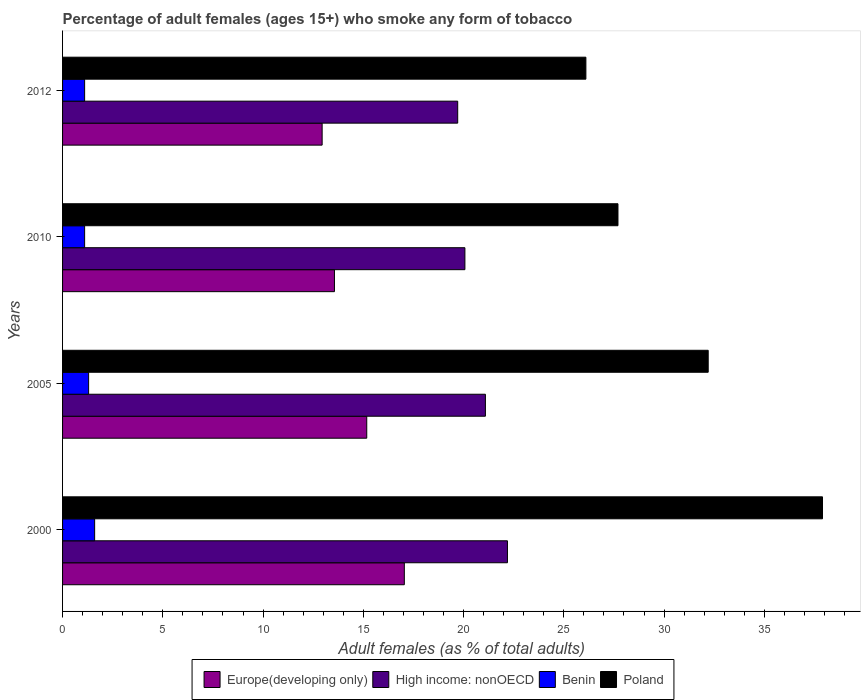How many different coloured bars are there?
Your response must be concise. 4. How many groups of bars are there?
Offer a very short reply. 4. What is the percentage of adult females who smoke in Benin in 2012?
Provide a short and direct response. 1.1. Across all years, what is the maximum percentage of adult females who smoke in Europe(developing only)?
Provide a succinct answer. 17.04. Across all years, what is the minimum percentage of adult females who smoke in Europe(developing only)?
Ensure brevity in your answer.  12.95. What is the difference between the percentage of adult females who smoke in High income: nonOECD in 2005 and that in 2012?
Keep it short and to the point. 1.38. What is the difference between the percentage of adult females who smoke in High income: nonOECD in 2010 and the percentage of adult females who smoke in Poland in 2012?
Your answer should be very brief. -6.03. What is the average percentage of adult females who smoke in Europe(developing only) per year?
Provide a short and direct response. 14.68. In the year 2000, what is the difference between the percentage of adult females who smoke in High income: nonOECD and percentage of adult females who smoke in Europe(developing only)?
Ensure brevity in your answer.  5.14. What is the ratio of the percentage of adult females who smoke in High income: nonOECD in 2010 to that in 2012?
Ensure brevity in your answer.  1.02. What is the difference between the highest and the second highest percentage of adult females who smoke in Europe(developing only)?
Provide a short and direct response. 1.87. What is the difference between the highest and the lowest percentage of adult females who smoke in Europe(developing only)?
Your response must be concise. 4.1. In how many years, is the percentage of adult females who smoke in High income: nonOECD greater than the average percentage of adult females who smoke in High income: nonOECD taken over all years?
Offer a terse response. 2. What does the 2nd bar from the top in 2005 represents?
Provide a succinct answer. Benin. What does the 4th bar from the bottom in 2012 represents?
Ensure brevity in your answer.  Poland. Is it the case that in every year, the sum of the percentage of adult females who smoke in Europe(developing only) and percentage of adult females who smoke in Benin is greater than the percentage of adult females who smoke in High income: nonOECD?
Provide a short and direct response. No. How many bars are there?
Keep it short and to the point. 16. Are all the bars in the graph horizontal?
Your response must be concise. Yes. How many years are there in the graph?
Provide a succinct answer. 4. What is the difference between two consecutive major ticks on the X-axis?
Provide a short and direct response. 5. Are the values on the major ticks of X-axis written in scientific E-notation?
Your answer should be very brief. No. Does the graph contain any zero values?
Your answer should be very brief. No. How are the legend labels stacked?
Your answer should be compact. Horizontal. What is the title of the graph?
Offer a very short reply. Percentage of adult females (ages 15+) who smoke any form of tobacco. Does "Nepal" appear as one of the legend labels in the graph?
Ensure brevity in your answer.  No. What is the label or title of the X-axis?
Ensure brevity in your answer.  Adult females (as % of total adults). What is the Adult females (as % of total adults) of Europe(developing only) in 2000?
Provide a succinct answer. 17.04. What is the Adult females (as % of total adults) of High income: nonOECD in 2000?
Provide a short and direct response. 22.19. What is the Adult females (as % of total adults) in Poland in 2000?
Ensure brevity in your answer.  37.9. What is the Adult females (as % of total adults) in Europe(developing only) in 2005?
Provide a short and direct response. 15.17. What is the Adult females (as % of total adults) in High income: nonOECD in 2005?
Make the answer very short. 21.09. What is the Adult females (as % of total adults) of Poland in 2005?
Offer a very short reply. 32.2. What is the Adult females (as % of total adults) in Europe(developing only) in 2010?
Your answer should be very brief. 13.56. What is the Adult females (as % of total adults) of High income: nonOECD in 2010?
Your answer should be very brief. 20.07. What is the Adult females (as % of total adults) of Benin in 2010?
Offer a very short reply. 1.1. What is the Adult females (as % of total adults) of Poland in 2010?
Provide a succinct answer. 27.7. What is the Adult females (as % of total adults) in Europe(developing only) in 2012?
Your answer should be very brief. 12.95. What is the Adult females (as % of total adults) of High income: nonOECD in 2012?
Your response must be concise. 19.71. What is the Adult females (as % of total adults) of Poland in 2012?
Offer a terse response. 26.1. Across all years, what is the maximum Adult females (as % of total adults) of Europe(developing only)?
Your response must be concise. 17.04. Across all years, what is the maximum Adult females (as % of total adults) in High income: nonOECD?
Your answer should be very brief. 22.19. Across all years, what is the maximum Adult females (as % of total adults) in Poland?
Make the answer very short. 37.9. Across all years, what is the minimum Adult females (as % of total adults) in Europe(developing only)?
Offer a terse response. 12.95. Across all years, what is the minimum Adult females (as % of total adults) of High income: nonOECD?
Your answer should be compact. 19.71. Across all years, what is the minimum Adult females (as % of total adults) of Poland?
Your answer should be very brief. 26.1. What is the total Adult females (as % of total adults) of Europe(developing only) in the graph?
Make the answer very short. 58.72. What is the total Adult females (as % of total adults) of High income: nonOECD in the graph?
Make the answer very short. 83.05. What is the total Adult females (as % of total adults) in Poland in the graph?
Provide a succinct answer. 123.9. What is the difference between the Adult females (as % of total adults) in Europe(developing only) in 2000 and that in 2005?
Keep it short and to the point. 1.87. What is the difference between the Adult females (as % of total adults) of High income: nonOECD in 2000 and that in 2005?
Your answer should be very brief. 1.1. What is the difference between the Adult females (as % of total adults) of Benin in 2000 and that in 2005?
Provide a succinct answer. 0.3. What is the difference between the Adult females (as % of total adults) of Europe(developing only) in 2000 and that in 2010?
Make the answer very short. 3.48. What is the difference between the Adult females (as % of total adults) in High income: nonOECD in 2000 and that in 2010?
Keep it short and to the point. 2.12. What is the difference between the Adult females (as % of total adults) in Benin in 2000 and that in 2010?
Offer a terse response. 0.5. What is the difference between the Adult females (as % of total adults) of Poland in 2000 and that in 2010?
Keep it short and to the point. 10.2. What is the difference between the Adult females (as % of total adults) of Europe(developing only) in 2000 and that in 2012?
Offer a terse response. 4.1. What is the difference between the Adult females (as % of total adults) of High income: nonOECD in 2000 and that in 2012?
Make the answer very short. 2.48. What is the difference between the Adult females (as % of total adults) in Poland in 2000 and that in 2012?
Offer a terse response. 11.8. What is the difference between the Adult females (as % of total adults) of Europe(developing only) in 2005 and that in 2010?
Give a very brief answer. 1.61. What is the difference between the Adult females (as % of total adults) in High income: nonOECD in 2005 and that in 2010?
Ensure brevity in your answer.  1.02. What is the difference between the Adult females (as % of total adults) in Benin in 2005 and that in 2010?
Your answer should be compact. 0.2. What is the difference between the Adult females (as % of total adults) in Poland in 2005 and that in 2010?
Provide a succinct answer. 4.5. What is the difference between the Adult females (as % of total adults) in Europe(developing only) in 2005 and that in 2012?
Offer a terse response. 2.22. What is the difference between the Adult females (as % of total adults) in High income: nonOECD in 2005 and that in 2012?
Provide a succinct answer. 1.38. What is the difference between the Adult females (as % of total adults) of Benin in 2005 and that in 2012?
Make the answer very short. 0.2. What is the difference between the Adult females (as % of total adults) in Poland in 2005 and that in 2012?
Give a very brief answer. 6.1. What is the difference between the Adult females (as % of total adults) of Europe(developing only) in 2010 and that in 2012?
Make the answer very short. 0.61. What is the difference between the Adult females (as % of total adults) in High income: nonOECD in 2010 and that in 2012?
Your answer should be very brief. 0.36. What is the difference between the Adult females (as % of total adults) in Benin in 2010 and that in 2012?
Make the answer very short. 0. What is the difference between the Adult females (as % of total adults) in Poland in 2010 and that in 2012?
Keep it short and to the point. 1.6. What is the difference between the Adult females (as % of total adults) of Europe(developing only) in 2000 and the Adult females (as % of total adults) of High income: nonOECD in 2005?
Your answer should be very brief. -4.04. What is the difference between the Adult females (as % of total adults) of Europe(developing only) in 2000 and the Adult females (as % of total adults) of Benin in 2005?
Make the answer very short. 15.74. What is the difference between the Adult females (as % of total adults) in Europe(developing only) in 2000 and the Adult females (as % of total adults) in Poland in 2005?
Give a very brief answer. -15.16. What is the difference between the Adult females (as % of total adults) of High income: nonOECD in 2000 and the Adult females (as % of total adults) of Benin in 2005?
Your response must be concise. 20.89. What is the difference between the Adult females (as % of total adults) of High income: nonOECD in 2000 and the Adult females (as % of total adults) of Poland in 2005?
Offer a very short reply. -10.01. What is the difference between the Adult females (as % of total adults) of Benin in 2000 and the Adult females (as % of total adults) of Poland in 2005?
Offer a terse response. -30.6. What is the difference between the Adult females (as % of total adults) in Europe(developing only) in 2000 and the Adult females (as % of total adults) in High income: nonOECD in 2010?
Your answer should be compact. -3.02. What is the difference between the Adult females (as % of total adults) of Europe(developing only) in 2000 and the Adult females (as % of total adults) of Benin in 2010?
Your answer should be compact. 15.94. What is the difference between the Adult females (as % of total adults) in Europe(developing only) in 2000 and the Adult females (as % of total adults) in Poland in 2010?
Your answer should be compact. -10.66. What is the difference between the Adult females (as % of total adults) of High income: nonOECD in 2000 and the Adult females (as % of total adults) of Benin in 2010?
Your response must be concise. 21.09. What is the difference between the Adult females (as % of total adults) in High income: nonOECD in 2000 and the Adult females (as % of total adults) in Poland in 2010?
Your response must be concise. -5.51. What is the difference between the Adult females (as % of total adults) of Benin in 2000 and the Adult females (as % of total adults) of Poland in 2010?
Offer a terse response. -26.1. What is the difference between the Adult females (as % of total adults) in Europe(developing only) in 2000 and the Adult females (as % of total adults) in High income: nonOECD in 2012?
Your answer should be compact. -2.66. What is the difference between the Adult females (as % of total adults) in Europe(developing only) in 2000 and the Adult females (as % of total adults) in Benin in 2012?
Make the answer very short. 15.94. What is the difference between the Adult females (as % of total adults) of Europe(developing only) in 2000 and the Adult females (as % of total adults) of Poland in 2012?
Offer a terse response. -9.06. What is the difference between the Adult females (as % of total adults) of High income: nonOECD in 2000 and the Adult females (as % of total adults) of Benin in 2012?
Your answer should be compact. 21.09. What is the difference between the Adult females (as % of total adults) in High income: nonOECD in 2000 and the Adult females (as % of total adults) in Poland in 2012?
Your answer should be compact. -3.91. What is the difference between the Adult females (as % of total adults) in Benin in 2000 and the Adult females (as % of total adults) in Poland in 2012?
Offer a very short reply. -24.5. What is the difference between the Adult females (as % of total adults) of Europe(developing only) in 2005 and the Adult females (as % of total adults) of High income: nonOECD in 2010?
Offer a very short reply. -4.9. What is the difference between the Adult females (as % of total adults) of Europe(developing only) in 2005 and the Adult females (as % of total adults) of Benin in 2010?
Provide a succinct answer. 14.07. What is the difference between the Adult females (as % of total adults) of Europe(developing only) in 2005 and the Adult females (as % of total adults) of Poland in 2010?
Your response must be concise. -12.53. What is the difference between the Adult females (as % of total adults) in High income: nonOECD in 2005 and the Adult females (as % of total adults) in Benin in 2010?
Offer a very short reply. 19.99. What is the difference between the Adult females (as % of total adults) in High income: nonOECD in 2005 and the Adult females (as % of total adults) in Poland in 2010?
Offer a very short reply. -6.61. What is the difference between the Adult females (as % of total adults) in Benin in 2005 and the Adult females (as % of total adults) in Poland in 2010?
Keep it short and to the point. -26.4. What is the difference between the Adult females (as % of total adults) in Europe(developing only) in 2005 and the Adult females (as % of total adults) in High income: nonOECD in 2012?
Your answer should be very brief. -4.54. What is the difference between the Adult females (as % of total adults) in Europe(developing only) in 2005 and the Adult females (as % of total adults) in Benin in 2012?
Give a very brief answer. 14.07. What is the difference between the Adult females (as % of total adults) of Europe(developing only) in 2005 and the Adult females (as % of total adults) of Poland in 2012?
Make the answer very short. -10.93. What is the difference between the Adult females (as % of total adults) in High income: nonOECD in 2005 and the Adult females (as % of total adults) in Benin in 2012?
Provide a succinct answer. 19.99. What is the difference between the Adult females (as % of total adults) in High income: nonOECD in 2005 and the Adult females (as % of total adults) in Poland in 2012?
Your response must be concise. -5.01. What is the difference between the Adult females (as % of total adults) of Benin in 2005 and the Adult females (as % of total adults) of Poland in 2012?
Keep it short and to the point. -24.8. What is the difference between the Adult females (as % of total adults) of Europe(developing only) in 2010 and the Adult females (as % of total adults) of High income: nonOECD in 2012?
Your answer should be compact. -6.15. What is the difference between the Adult females (as % of total adults) of Europe(developing only) in 2010 and the Adult females (as % of total adults) of Benin in 2012?
Your answer should be compact. 12.46. What is the difference between the Adult females (as % of total adults) of Europe(developing only) in 2010 and the Adult females (as % of total adults) of Poland in 2012?
Your answer should be compact. -12.54. What is the difference between the Adult females (as % of total adults) in High income: nonOECD in 2010 and the Adult females (as % of total adults) in Benin in 2012?
Offer a terse response. 18.97. What is the difference between the Adult females (as % of total adults) of High income: nonOECD in 2010 and the Adult females (as % of total adults) of Poland in 2012?
Provide a succinct answer. -6.03. What is the average Adult females (as % of total adults) of Europe(developing only) per year?
Make the answer very short. 14.68. What is the average Adult females (as % of total adults) of High income: nonOECD per year?
Ensure brevity in your answer.  20.76. What is the average Adult females (as % of total adults) of Benin per year?
Offer a terse response. 1.27. What is the average Adult females (as % of total adults) of Poland per year?
Make the answer very short. 30.98. In the year 2000, what is the difference between the Adult females (as % of total adults) of Europe(developing only) and Adult females (as % of total adults) of High income: nonOECD?
Provide a short and direct response. -5.14. In the year 2000, what is the difference between the Adult females (as % of total adults) in Europe(developing only) and Adult females (as % of total adults) in Benin?
Ensure brevity in your answer.  15.44. In the year 2000, what is the difference between the Adult females (as % of total adults) of Europe(developing only) and Adult females (as % of total adults) of Poland?
Offer a terse response. -20.86. In the year 2000, what is the difference between the Adult females (as % of total adults) of High income: nonOECD and Adult females (as % of total adults) of Benin?
Offer a terse response. 20.59. In the year 2000, what is the difference between the Adult females (as % of total adults) of High income: nonOECD and Adult females (as % of total adults) of Poland?
Provide a short and direct response. -15.71. In the year 2000, what is the difference between the Adult females (as % of total adults) of Benin and Adult females (as % of total adults) of Poland?
Offer a terse response. -36.3. In the year 2005, what is the difference between the Adult females (as % of total adults) in Europe(developing only) and Adult females (as % of total adults) in High income: nonOECD?
Your response must be concise. -5.92. In the year 2005, what is the difference between the Adult females (as % of total adults) in Europe(developing only) and Adult females (as % of total adults) in Benin?
Ensure brevity in your answer.  13.87. In the year 2005, what is the difference between the Adult females (as % of total adults) in Europe(developing only) and Adult females (as % of total adults) in Poland?
Give a very brief answer. -17.03. In the year 2005, what is the difference between the Adult females (as % of total adults) in High income: nonOECD and Adult females (as % of total adults) in Benin?
Offer a terse response. 19.79. In the year 2005, what is the difference between the Adult females (as % of total adults) of High income: nonOECD and Adult females (as % of total adults) of Poland?
Keep it short and to the point. -11.11. In the year 2005, what is the difference between the Adult females (as % of total adults) of Benin and Adult females (as % of total adults) of Poland?
Your answer should be compact. -30.9. In the year 2010, what is the difference between the Adult females (as % of total adults) of Europe(developing only) and Adult females (as % of total adults) of High income: nonOECD?
Your answer should be compact. -6.51. In the year 2010, what is the difference between the Adult females (as % of total adults) of Europe(developing only) and Adult females (as % of total adults) of Benin?
Ensure brevity in your answer.  12.46. In the year 2010, what is the difference between the Adult females (as % of total adults) of Europe(developing only) and Adult females (as % of total adults) of Poland?
Offer a terse response. -14.14. In the year 2010, what is the difference between the Adult females (as % of total adults) in High income: nonOECD and Adult females (as % of total adults) in Benin?
Ensure brevity in your answer.  18.97. In the year 2010, what is the difference between the Adult females (as % of total adults) of High income: nonOECD and Adult females (as % of total adults) of Poland?
Your response must be concise. -7.63. In the year 2010, what is the difference between the Adult females (as % of total adults) in Benin and Adult females (as % of total adults) in Poland?
Keep it short and to the point. -26.6. In the year 2012, what is the difference between the Adult females (as % of total adults) in Europe(developing only) and Adult females (as % of total adults) in High income: nonOECD?
Offer a very short reply. -6.76. In the year 2012, what is the difference between the Adult females (as % of total adults) in Europe(developing only) and Adult females (as % of total adults) in Benin?
Provide a succinct answer. 11.85. In the year 2012, what is the difference between the Adult females (as % of total adults) of Europe(developing only) and Adult females (as % of total adults) of Poland?
Your answer should be compact. -13.15. In the year 2012, what is the difference between the Adult females (as % of total adults) in High income: nonOECD and Adult females (as % of total adults) in Benin?
Your answer should be compact. 18.61. In the year 2012, what is the difference between the Adult females (as % of total adults) of High income: nonOECD and Adult females (as % of total adults) of Poland?
Offer a terse response. -6.39. In the year 2012, what is the difference between the Adult females (as % of total adults) in Benin and Adult females (as % of total adults) in Poland?
Keep it short and to the point. -25. What is the ratio of the Adult females (as % of total adults) in Europe(developing only) in 2000 to that in 2005?
Keep it short and to the point. 1.12. What is the ratio of the Adult females (as % of total adults) in High income: nonOECD in 2000 to that in 2005?
Your answer should be compact. 1.05. What is the ratio of the Adult females (as % of total adults) in Benin in 2000 to that in 2005?
Keep it short and to the point. 1.23. What is the ratio of the Adult females (as % of total adults) of Poland in 2000 to that in 2005?
Ensure brevity in your answer.  1.18. What is the ratio of the Adult females (as % of total adults) of Europe(developing only) in 2000 to that in 2010?
Your response must be concise. 1.26. What is the ratio of the Adult females (as % of total adults) of High income: nonOECD in 2000 to that in 2010?
Offer a terse response. 1.11. What is the ratio of the Adult females (as % of total adults) in Benin in 2000 to that in 2010?
Your answer should be very brief. 1.45. What is the ratio of the Adult females (as % of total adults) in Poland in 2000 to that in 2010?
Offer a terse response. 1.37. What is the ratio of the Adult females (as % of total adults) in Europe(developing only) in 2000 to that in 2012?
Your answer should be compact. 1.32. What is the ratio of the Adult females (as % of total adults) of High income: nonOECD in 2000 to that in 2012?
Your answer should be compact. 1.13. What is the ratio of the Adult females (as % of total adults) in Benin in 2000 to that in 2012?
Your answer should be very brief. 1.45. What is the ratio of the Adult females (as % of total adults) of Poland in 2000 to that in 2012?
Your response must be concise. 1.45. What is the ratio of the Adult females (as % of total adults) of Europe(developing only) in 2005 to that in 2010?
Your answer should be compact. 1.12. What is the ratio of the Adult females (as % of total adults) of High income: nonOECD in 2005 to that in 2010?
Your response must be concise. 1.05. What is the ratio of the Adult females (as % of total adults) of Benin in 2005 to that in 2010?
Your answer should be compact. 1.18. What is the ratio of the Adult females (as % of total adults) of Poland in 2005 to that in 2010?
Provide a short and direct response. 1.16. What is the ratio of the Adult females (as % of total adults) of Europe(developing only) in 2005 to that in 2012?
Give a very brief answer. 1.17. What is the ratio of the Adult females (as % of total adults) of High income: nonOECD in 2005 to that in 2012?
Give a very brief answer. 1.07. What is the ratio of the Adult females (as % of total adults) of Benin in 2005 to that in 2012?
Your response must be concise. 1.18. What is the ratio of the Adult females (as % of total adults) in Poland in 2005 to that in 2012?
Your answer should be very brief. 1.23. What is the ratio of the Adult females (as % of total adults) of Europe(developing only) in 2010 to that in 2012?
Your answer should be very brief. 1.05. What is the ratio of the Adult females (as % of total adults) in High income: nonOECD in 2010 to that in 2012?
Provide a succinct answer. 1.02. What is the ratio of the Adult females (as % of total adults) in Benin in 2010 to that in 2012?
Ensure brevity in your answer.  1. What is the ratio of the Adult females (as % of total adults) in Poland in 2010 to that in 2012?
Make the answer very short. 1.06. What is the difference between the highest and the second highest Adult females (as % of total adults) in Europe(developing only)?
Offer a very short reply. 1.87. What is the difference between the highest and the second highest Adult females (as % of total adults) in High income: nonOECD?
Provide a short and direct response. 1.1. What is the difference between the highest and the second highest Adult females (as % of total adults) in Benin?
Offer a terse response. 0.3. What is the difference between the highest and the second highest Adult females (as % of total adults) in Poland?
Make the answer very short. 5.7. What is the difference between the highest and the lowest Adult females (as % of total adults) of Europe(developing only)?
Provide a short and direct response. 4.1. What is the difference between the highest and the lowest Adult females (as % of total adults) in High income: nonOECD?
Your answer should be very brief. 2.48. What is the difference between the highest and the lowest Adult females (as % of total adults) of Benin?
Offer a very short reply. 0.5. 